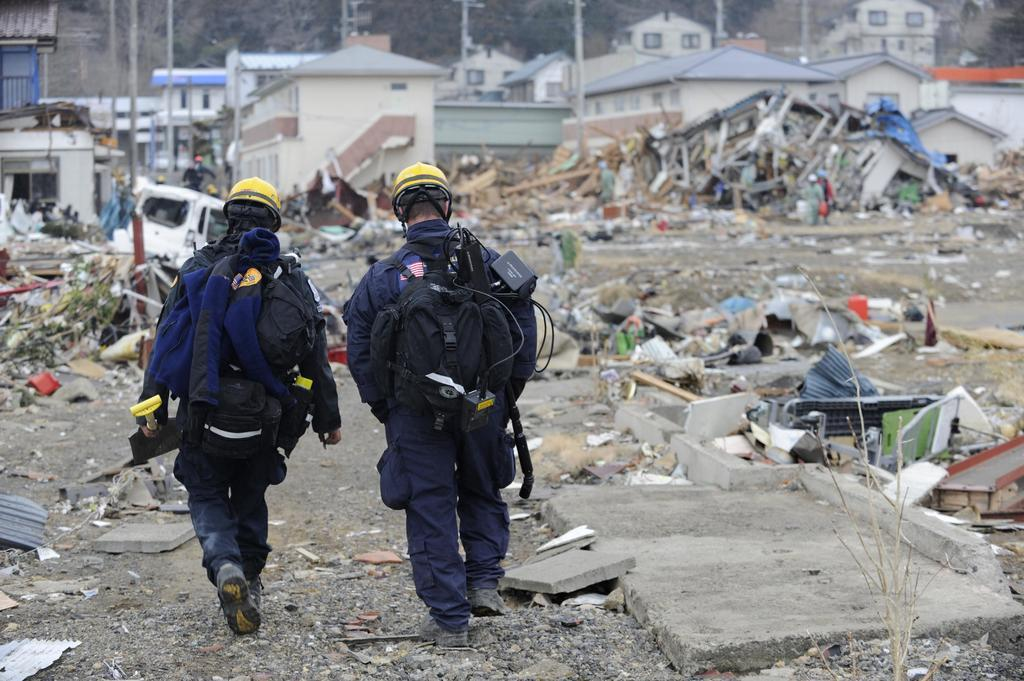What are the two persons in the image doing? The two persons in the image are walking. What are the persons wearing on their upper bodies? The persons are wearing blue coats. What are the persons wearing on their lower bodies? The persons are wearing trousers. What are the persons wearing on their heads? The persons are wearing yellow caps. What can be seen in the background of the image? There are houses visible at the back side of the image. What type of hose is being used by the persons in the image? There is no hose visible in the image; the persons are simply walking. Which knee is the person on the left using to walk in the image? The image does not provide enough detail to determine which knee the person on the left is using to walk. 